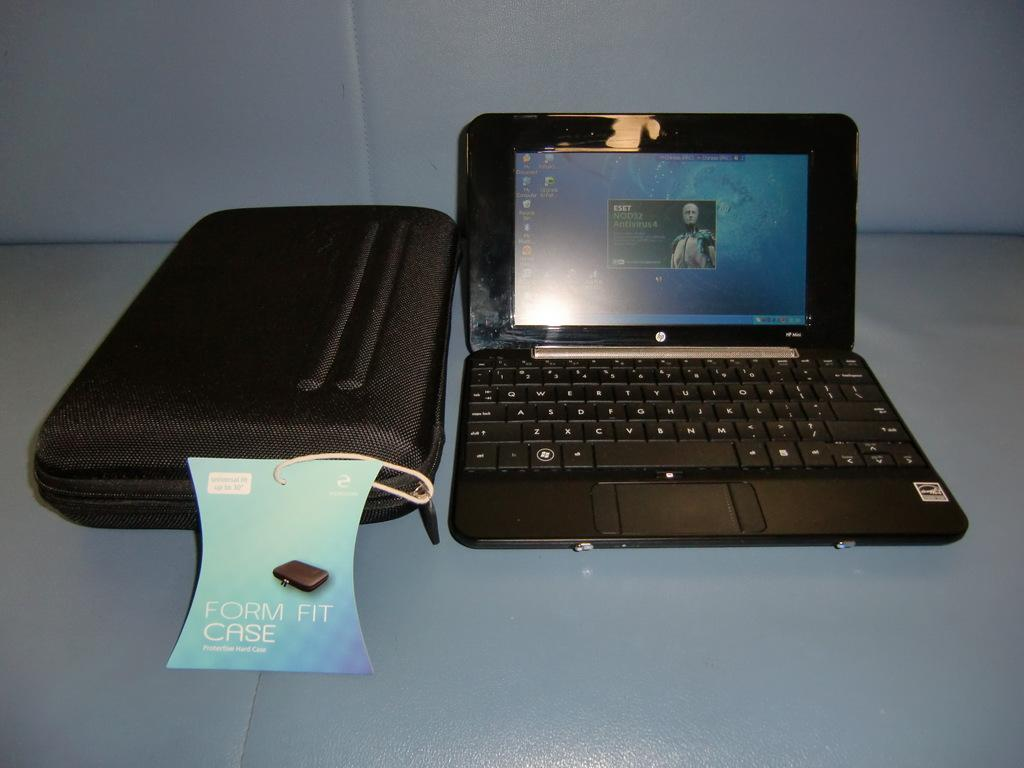Provide a one-sentence caption for the provided image. An old laptop and form fit case on a blue couch. 